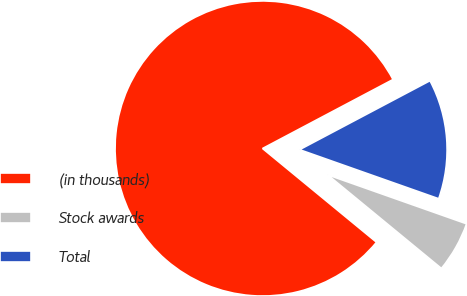<chart> <loc_0><loc_0><loc_500><loc_500><pie_chart><fcel>(in thousands)<fcel>Stock awards<fcel>Total<nl><fcel>81.3%<fcel>5.56%<fcel>13.14%<nl></chart> 